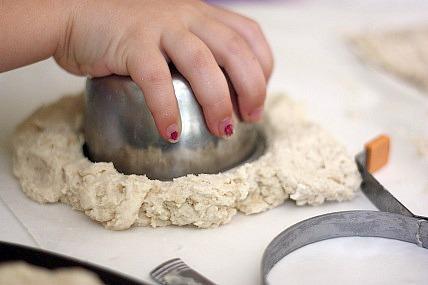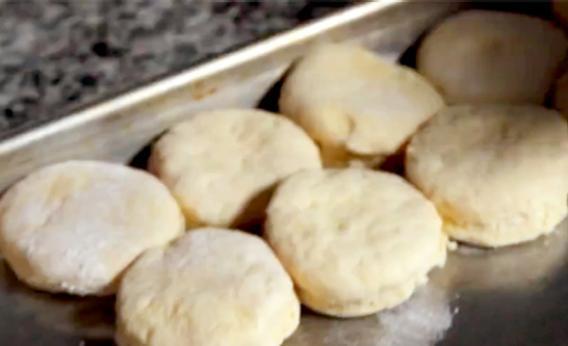The first image is the image on the left, the second image is the image on the right. Analyze the images presented: Is the assertion "Some dough is shaped like a cylinder." valid? Answer yes or no. No. 